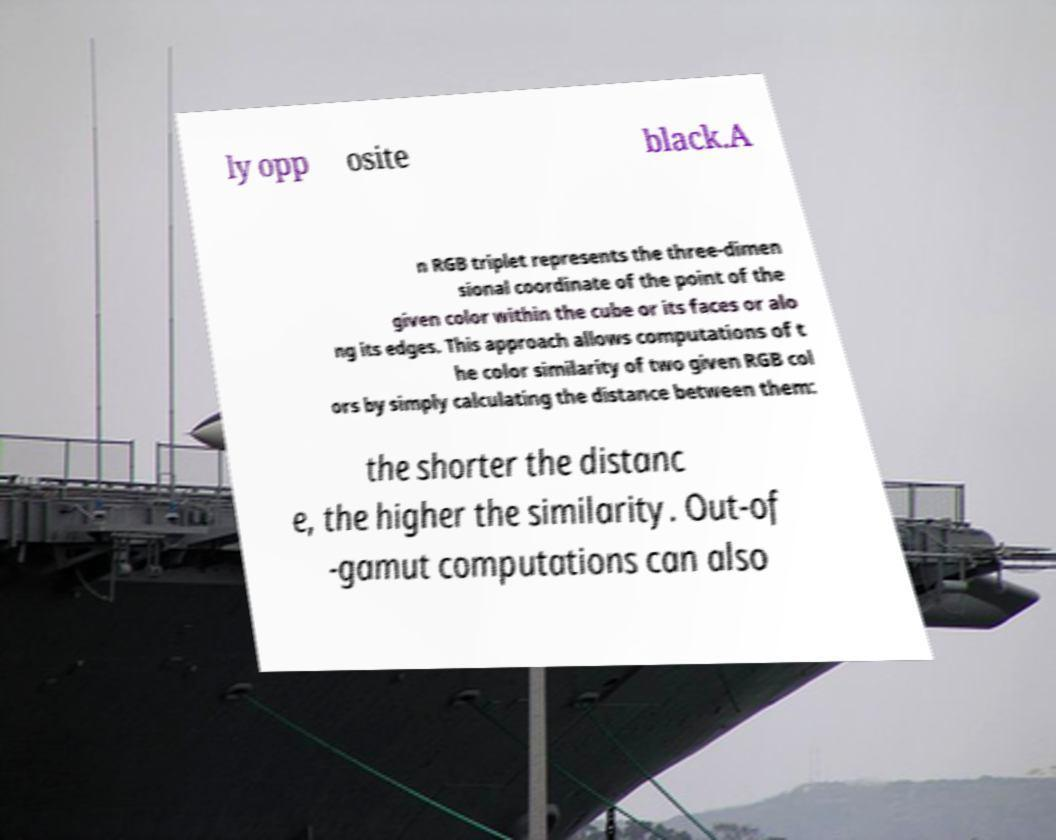There's text embedded in this image that I need extracted. Can you transcribe it verbatim? ly opp osite black.A n RGB triplet represents the three-dimen sional coordinate of the point of the given color within the cube or its faces or alo ng its edges. This approach allows computations of t he color similarity of two given RGB col ors by simply calculating the distance between them: the shorter the distanc e, the higher the similarity. Out-of -gamut computations can also 